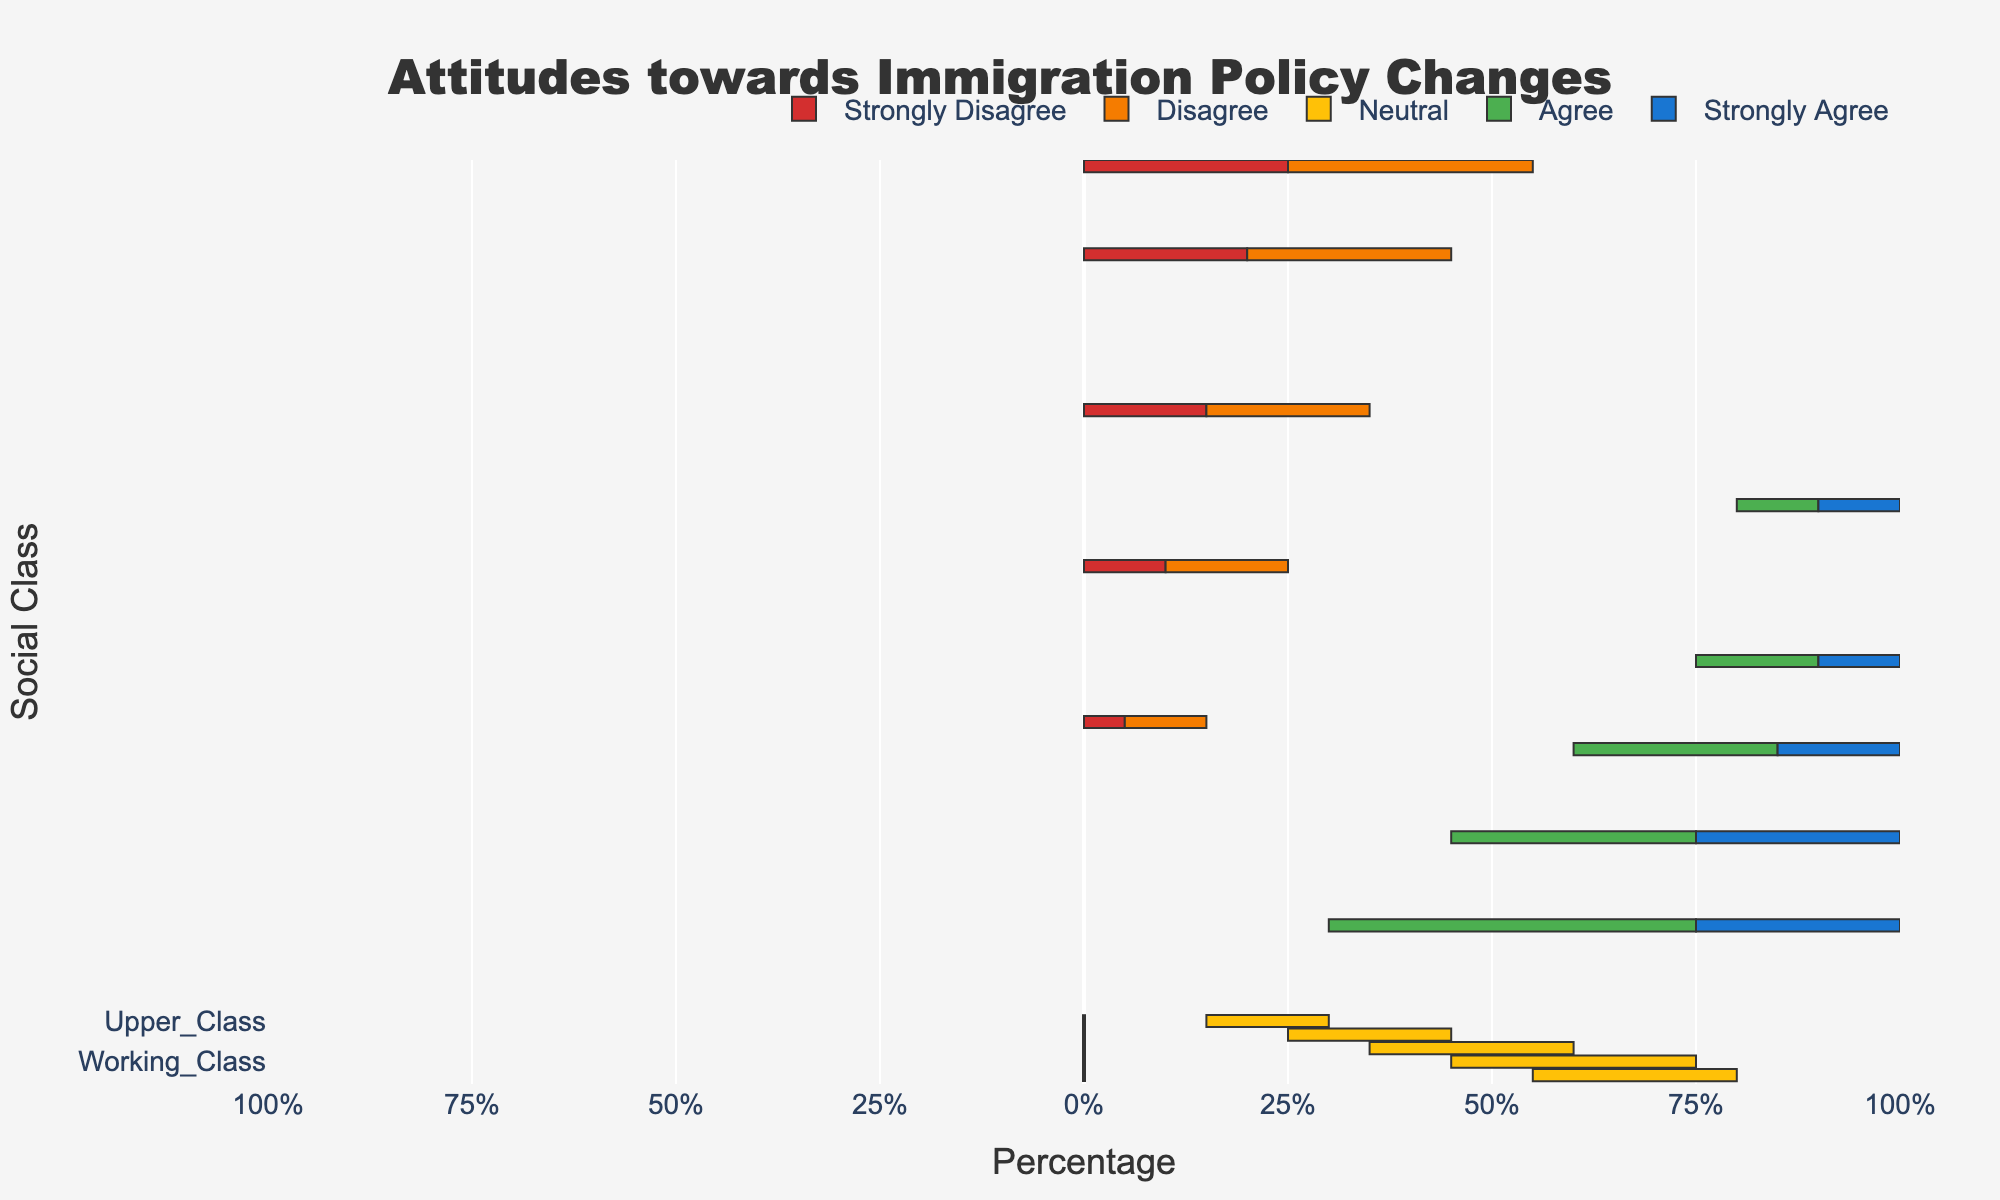What percentage of the Upper Class are neutral towards immigration policy changes? In the Upper Class, the "Neutral" category is 15%. Simply look at the bar labeled "Upper Class" and the segment labeled "Neutral" to find this percentage.
Answer: 15% Which socioeconomic class has the highest percentage of Strongly Agree toward immigration policy changes? To determine the class with the highest "Strongly Agree" percentage, compare the segments labeled "Strongly Agree" across all social classes. The Upper Class has the highest "Strongly Agree" percentage at 25%.
Answer: Upper Class What's the difference in the percentage of Strongly Disagree between the Upper Class and Lower Class? Observe the "Strongly Disagree" segment for both classes. The Upper Class has 5% and the Lower Class has 25%. The difference is 25% - 5% = 20%.
Answer: 20% What is the total percentage of people who Agree or Strongly Agree in the Upper Middle Class? Add the percentages of "Agree" and "Strongly Agree" for the Upper Middle Class. The Upper Middle Class has 30% who "Agree" and 25% who "Strongly Agree". Therefore, 30% + 25% = 55%.
Answer: 55% Compare the percentage of Neutral opinions between Middle Class and Working Class. Which class has a higher percentage? Look at the "Neutral" segments for both classes. The Middle Class has 25% while the Working Class has 30%. Hence, the Working Class has a higher percentage of Neutral opinions.
Answer: Working Class What is the average percentage of Strongly Agree across all socioeconomic classes? Sum the percentages of "Strongly Agree" for all classes and divide by the number of classes. The totals are: 25% (Upper Class) + 25% (Upper Middle Class) + 15% (Middle Class) + 10% (Working Class) + 10% (Lower Class) = 85%. There are 5 classes, so the average is 85% / 5 = 17%.
Answer: 17% Which socioeconomic class has the most balanced view (i.e., closest to equal percentages) across all five categories? To find the most balanced view, observe which class has the most even distribution of percentages across all categories. The Middle Class has a relatively even spread (15%, 20%, 25%, 25%, 15%), making it the most balanced.
Answer: Middle Class Which category of opinion has the smallest total percentage when summed across all socioeconomic classes? Add up the percentages of each opinion category across all classes and find the smallest total. "Strongly Disagree" sums to 5 + 10 + 15 + 20 + 25 = 75%, "Disagree" sums to 10 + 15 + 20 + 25 + 30 = 100%, "Neutral" sums to 15 + 20 + 25 + 30 + 25 = 115%, "Agree" sums to 45 + 30 + 25 + 15 + 10 = 125%, "Strongly Agree" sums to 25 + 25 + 15 + 10 + 10 = 85%. Hence, "Strongly Disagree" has the smallest total.
Answer: Strongly Disagree 